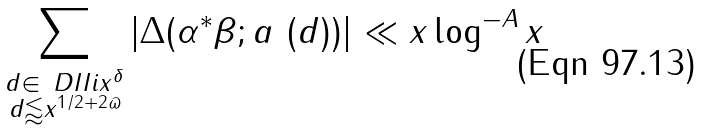Convert formula to latex. <formula><loc_0><loc_0><loc_500><loc_500>\sum _ { \substack { d \in \ D I { I } { i } { x ^ { \delta } } \\ d \lessapprox x ^ { 1 / 2 + 2 \varpi } } } | \Delta ( \alpha ^ { * } \beta ; a \ ( d ) ) | \ll x \log ^ { - A } x</formula> 